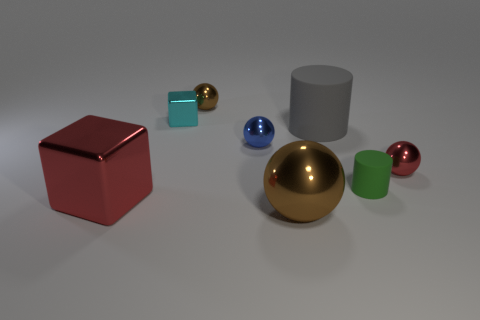There is a shiny thing that is the same color as the big shiny ball; what shape is it?
Offer a very short reply. Sphere. Does the metal ball that is in front of the green object have the same color as the ball behind the big gray rubber cylinder?
Provide a succinct answer. Yes. There is a large gray object that is the same material as the green object; what shape is it?
Provide a succinct answer. Cylinder. There is a metal ball that is in front of the metal block in front of the small red metal thing; what size is it?
Give a very brief answer. Large. The cube behind the small green rubber thing is what color?
Provide a succinct answer. Cyan. Are there any other big matte objects of the same shape as the green object?
Your answer should be very brief. Yes. Is the number of small green cylinders in front of the small rubber cylinder less than the number of small rubber cylinders in front of the small red ball?
Provide a short and direct response. Yes. The tiny rubber thing has what color?
Offer a terse response. Green. Are there any brown things that are in front of the brown metal thing behind the large gray object?
Give a very brief answer. Yes. How many green things are the same size as the blue shiny sphere?
Offer a very short reply. 1. 